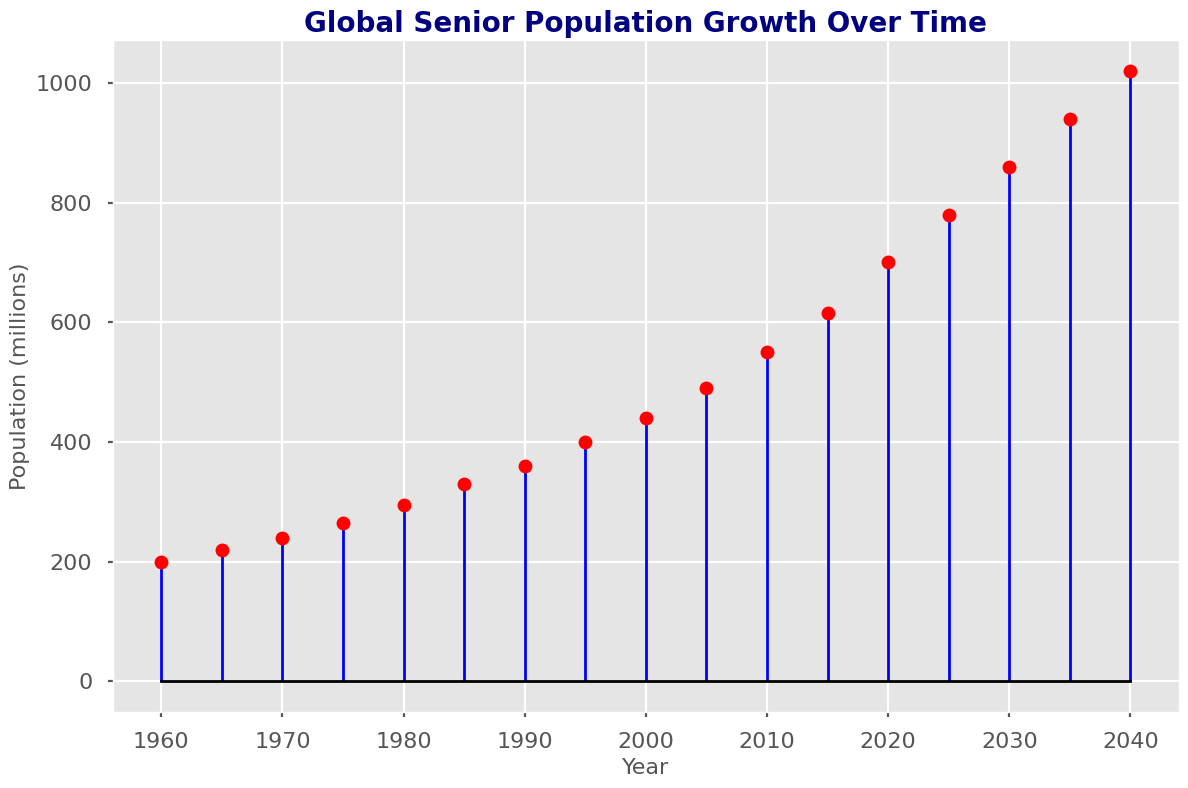What was the global senior population in 1970? According to the figure, the senior population for the year 1970 is marked by a red dot at the height corresponding to 240 million.
Answer: 240 million In what year did the global senior population first reach 400 million? By locating the year against the population values, we see that the red dot aligns with 400 million in the year 1995.
Answer: 1995 What is the increase in senior population from 2000 to 2010? By subtracting the population in the year 2000 (440 million) from the population in the year 2010 (550 million), we get 550 - 440 = 110 million.
Answer: 110 million Identify any years where the senior population increased by 50 million. Comparing the red dots, we notice that from 2000 (440 million) to 2005 (490 million), the population increased by 50 million.
Answer: 2000-2005 What is the estimated senior population in the year 2040? The last data point in the figure for the year 2040 shows a population of 1020 million.
Answer: 1020 million By how much did the senior population grow from 1960 to 2020? Subtract the population in 1960 (200 million) from the population in 2020 (700 million): 700 - 200 = 500 million.
Answer: 500 million Over which period did the senior population grow the fastest? By analyzing the steepness of the markers and lines, we see a rapid increase from 2010 (550 million) to 2025 (780 million), indicating a significant growth rate.
Answer: 2010-2025 Which decade showed the smallest increase in senior population? By examining the red dots for each decade, we observe the smallest increase between 1960 (200 million) and 1970 (240 million), with only a 40 million increase.
Answer: 1960-1970 What was the senior population in 1985 compared to 1995? The red dot for 1985 shows a population of 330 million, and for 1995, it shows 400 million. Comparing 330 million to 400 million, 1995 had a greater population.
Answer: 1995 had a greater population How does the senior population in 1975 compare to that in 1985? The red dot for 1975 shows 265 million, and for 1985, it shows 330 million. So, the population in 1985 is higher than in 1975.
Answer: 1985 is higher 